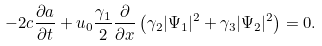<formula> <loc_0><loc_0><loc_500><loc_500>- 2 c \frac { \partial a } { \partial t } + u _ { 0 } \frac { \gamma _ { 1 } } { 2 } \frac { \partial } { \partial x } \left ( \gamma _ { 2 } | \Psi _ { 1 } | ^ { 2 } + \gamma _ { 3 } | \Psi _ { 2 } | ^ { 2 } \right ) = 0 .</formula> 